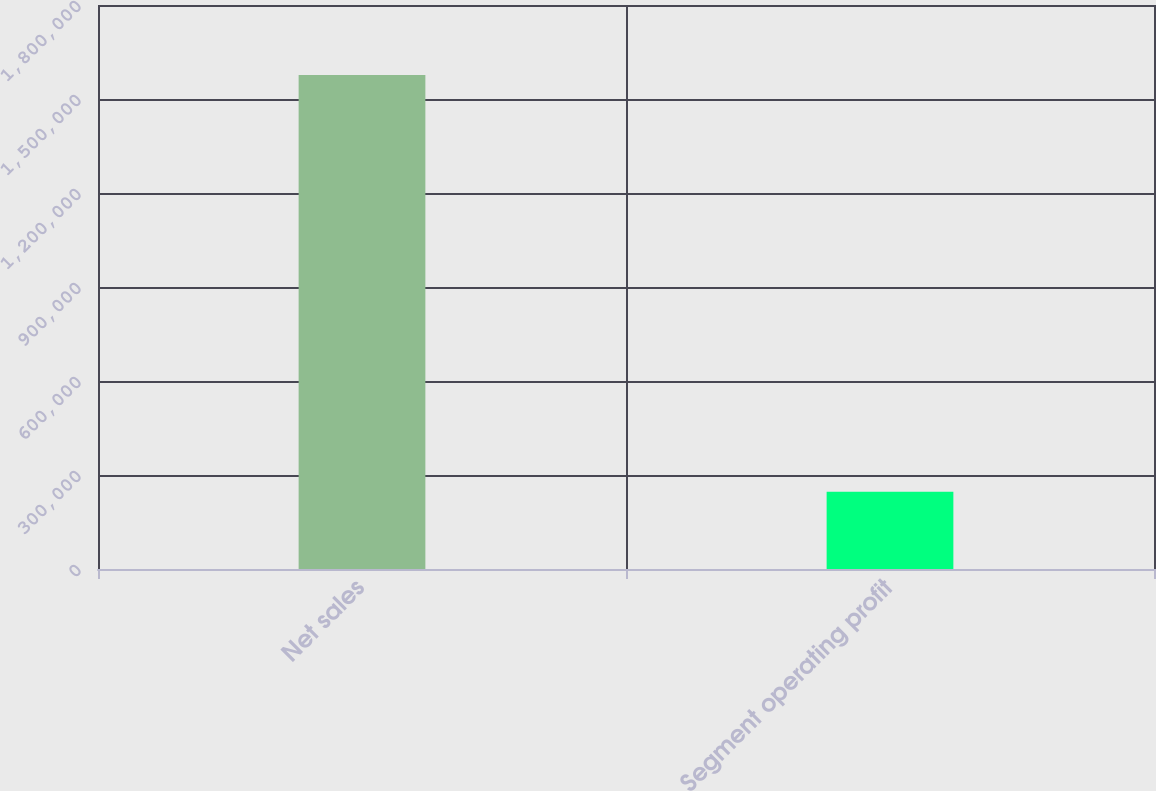<chart> <loc_0><loc_0><loc_500><loc_500><bar_chart><fcel>Net sales<fcel>Segment operating profit<nl><fcel>1.57672e+06<fcel>246508<nl></chart> 